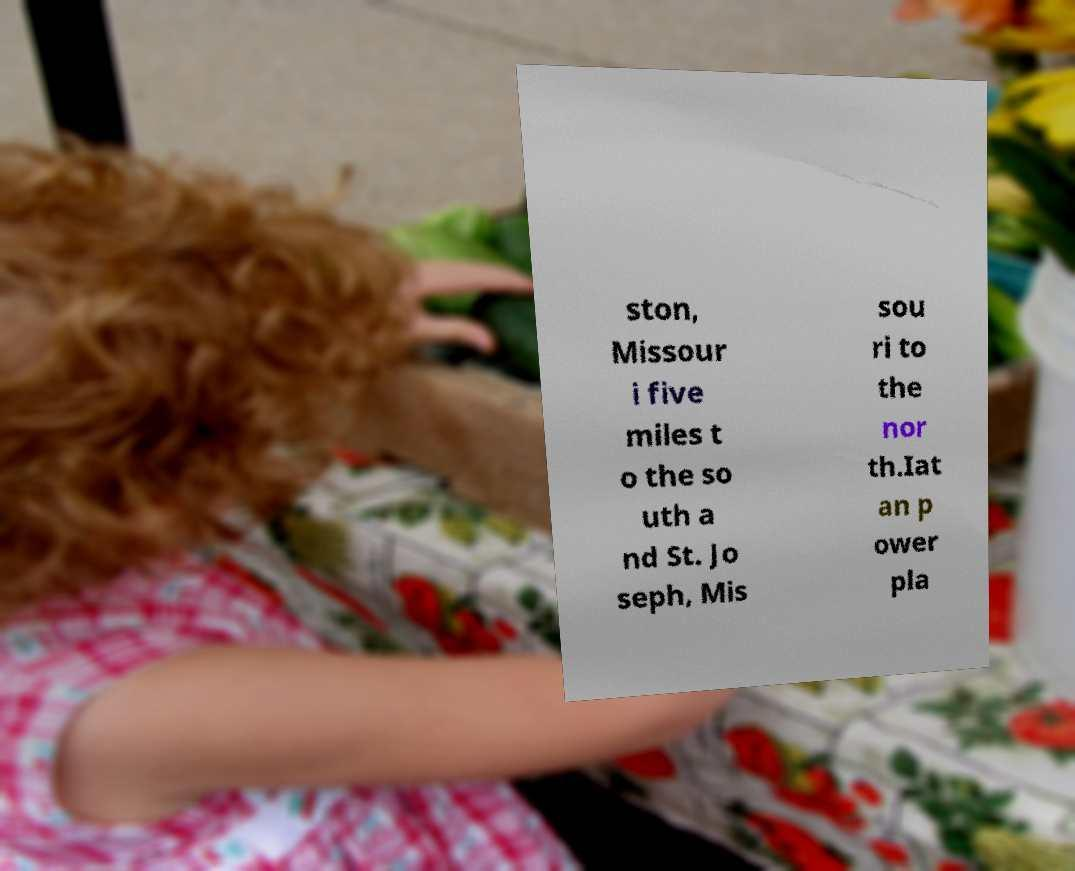For documentation purposes, I need the text within this image transcribed. Could you provide that? ston, Missour i five miles t o the so uth a nd St. Jo seph, Mis sou ri to the nor th.Iat an p ower pla 